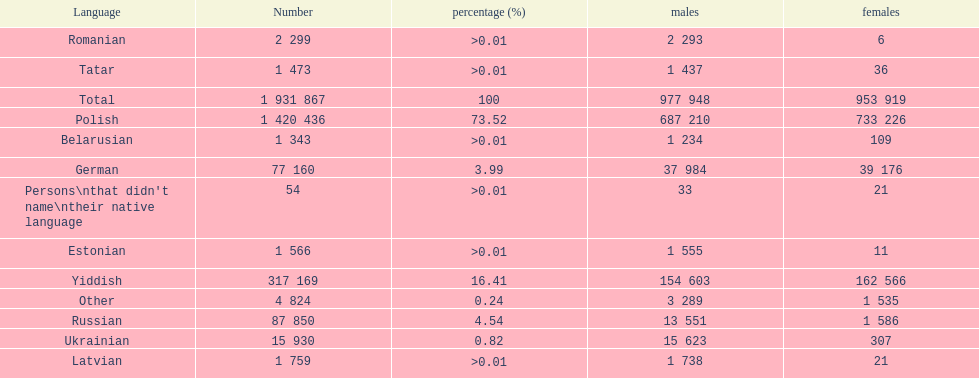What was the next most commonly spoken language in poland after russian? German. 